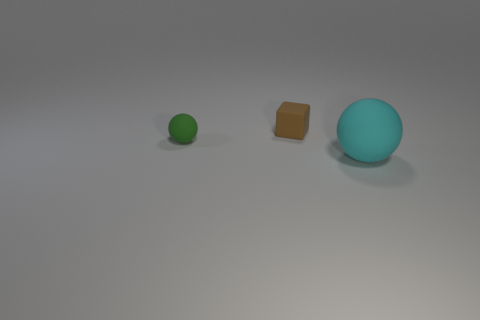Add 2 cyan things. How many objects exist? 5 Subtract all cyan spheres. How many spheres are left? 1 Subtract all balls. How many objects are left? 1 Subtract 1 spheres. How many spheres are left? 1 Add 3 big things. How many big things are left? 4 Add 2 small red rubber things. How many small red rubber things exist? 2 Subtract 0 purple spheres. How many objects are left? 3 Subtract all purple cubes. Subtract all purple balls. How many cubes are left? 1 Subtract all tiny blue metallic balls. Subtract all large balls. How many objects are left? 2 